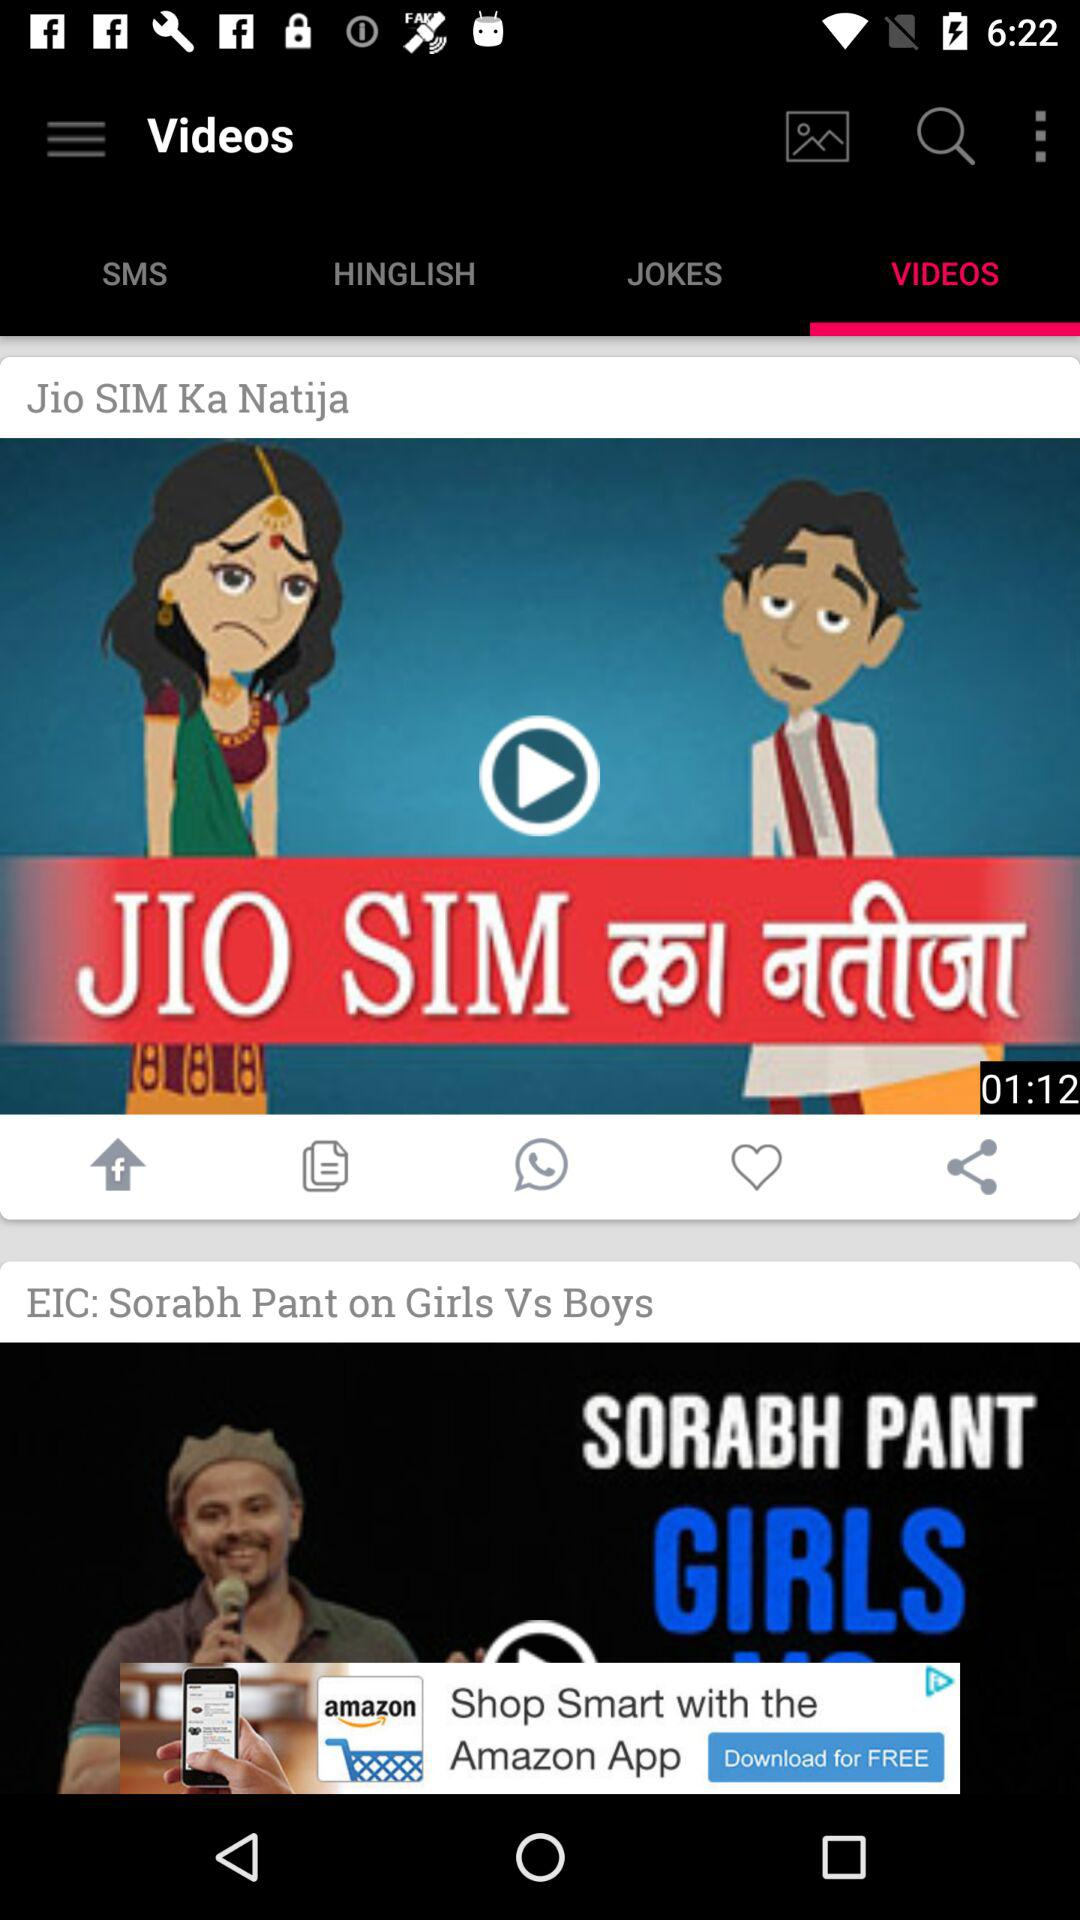What is the duration of "Jio SIM Ka Natija"? The duration is 1 minute 12 seconds. 